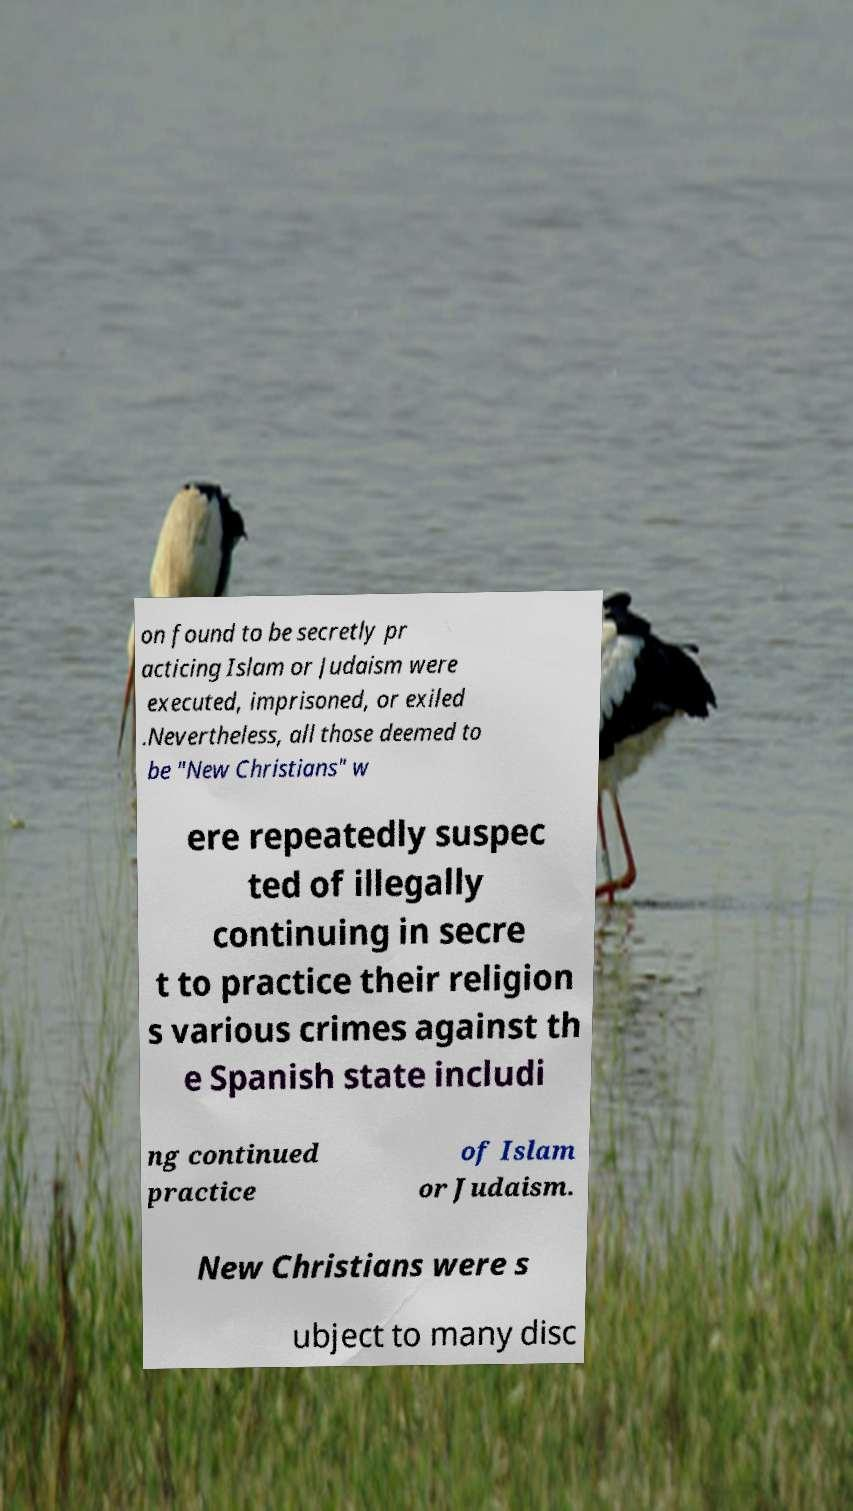Can you read and provide the text displayed in the image?This photo seems to have some interesting text. Can you extract and type it out for me? on found to be secretly pr acticing Islam or Judaism were executed, imprisoned, or exiled .Nevertheless, all those deemed to be "New Christians" w ere repeatedly suspec ted of illegally continuing in secre t to practice their religion s various crimes against th e Spanish state includi ng continued practice of Islam or Judaism. New Christians were s ubject to many disc 